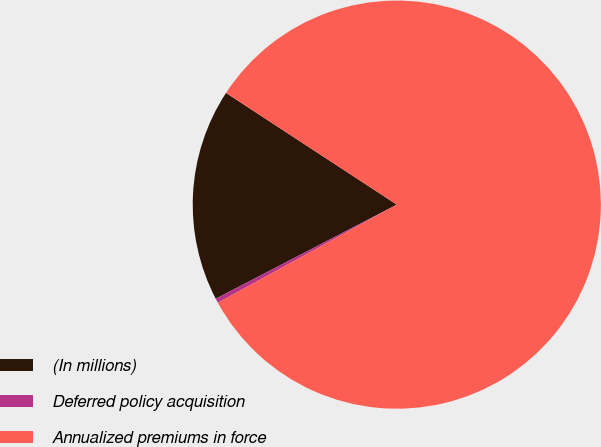Convert chart. <chart><loc_0><loc_0><loc_500><loc_500><pie_chart><fcel>(In millions)<fcel>Deferred policy acquisition<fcel>Annualized premiums in force<nl><fcel>16.85%<fcel>0.36%<fcel>82.79%<nl></chart> 